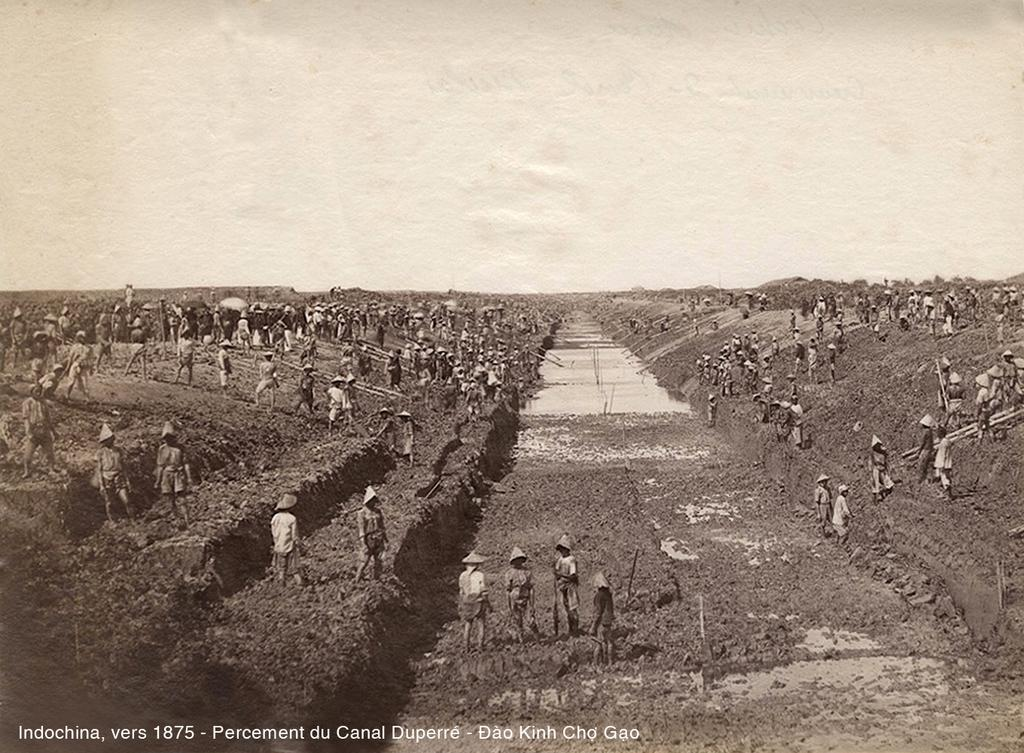What is happening in the image involving a group of people? The people in the image are digging the soil. What else can be seen in the image besides the people? There is a road in the image. Is there any text present in the image? Yes, there is text at the bottom of the image. What is visible at the top of the image? The sky is visible at the top of the image. What type of cloud is present in the image? There is no cloud present in the image; only the sky is visible at the top. 